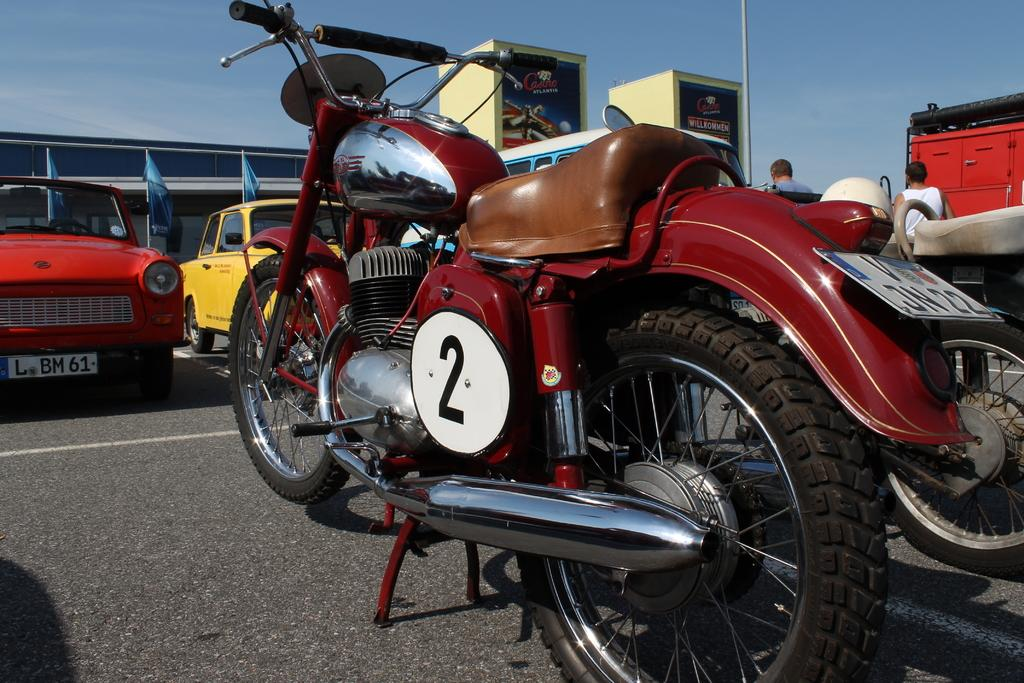<image>
Create a compact narrative representing the image presented. The motorcycle has a racing number of 2. 